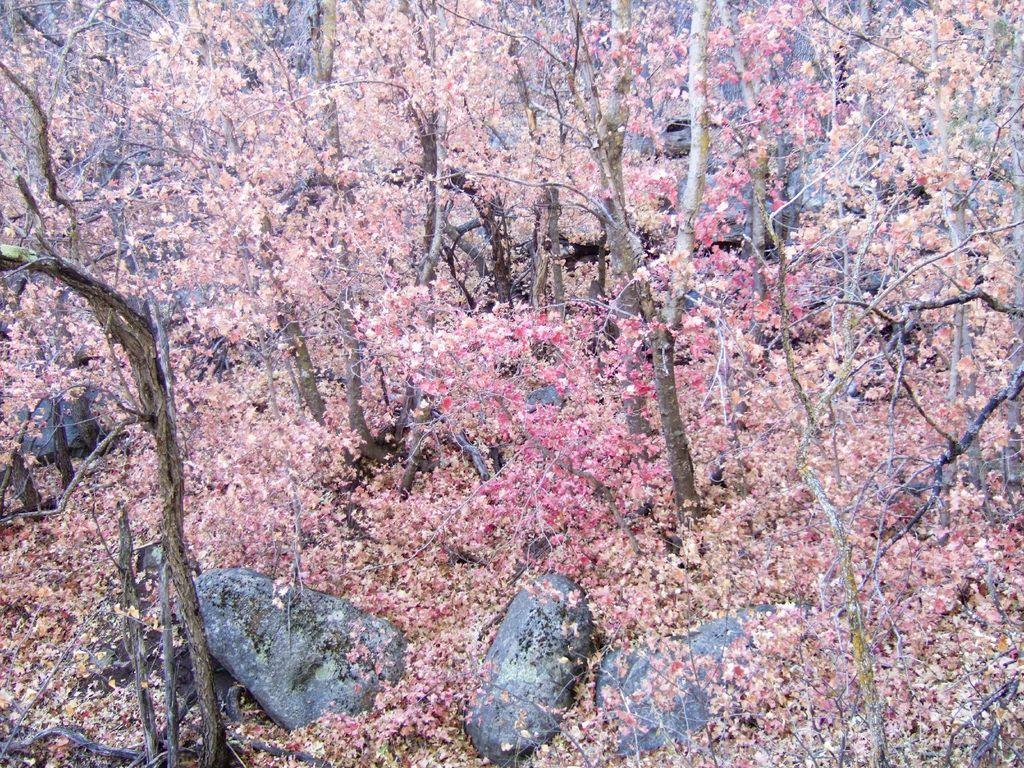What type of vegetation is present in the image? There are trees with small leaves in the image. What is on the ground in the image? There are leaves on the ground in the image. What can be seen at the bottom of the image? There are stones at the bottom of the image. What type of pan is being used to cook the celery in the image? There is no pan or celery present in the image. 